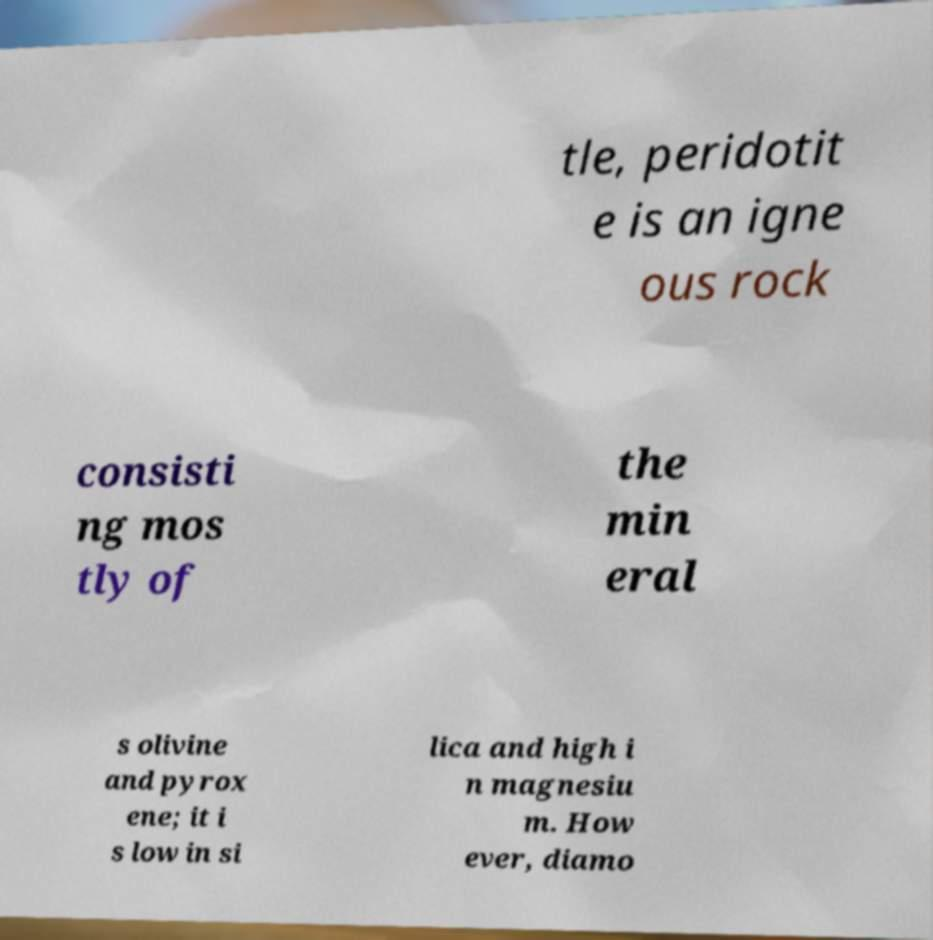There's text embedded in this image that I need extracted. Can you transcribe it verbatim? tle, peridotit e is an igne ous rock consisti ng mos tly of the min eral s olivine and pyrox ene; it i s low in si lica and high i n magnesiu m. How ever, diamo 